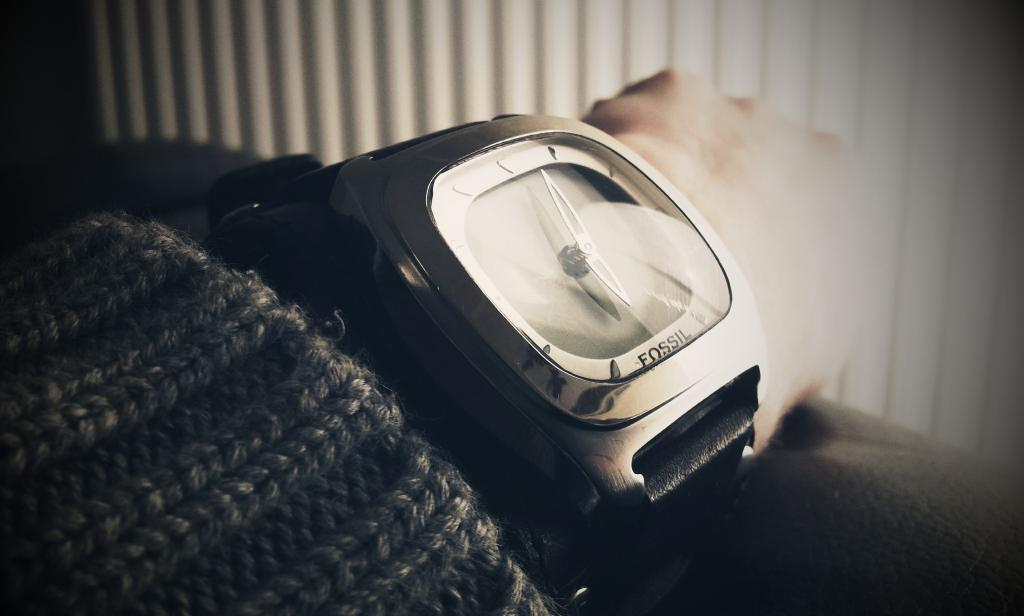<image>
Create a compact narrative representing the image presented. A wrist wearing a Fossil watch is resting on a gray surface. 